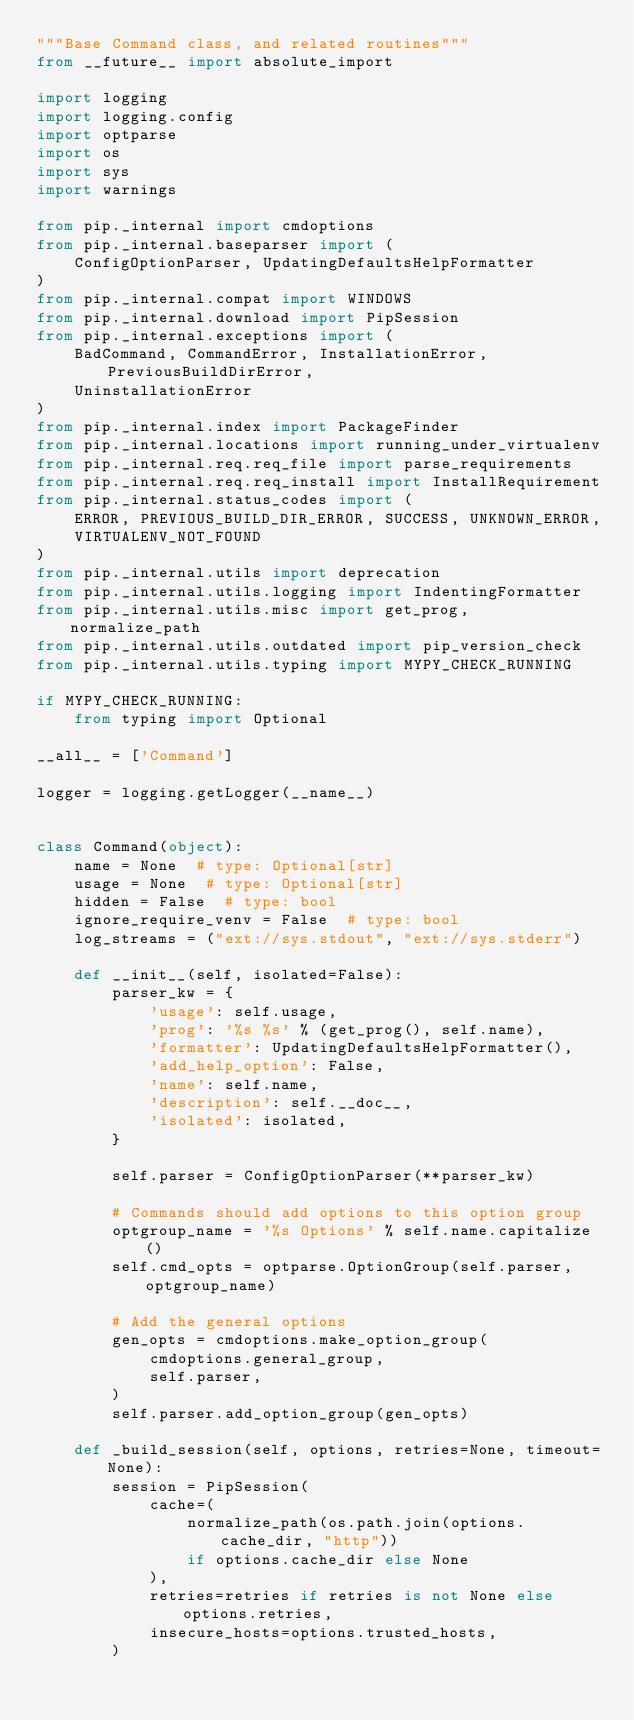<code> <loc_0><loc_0><loc_500><loc_500><_Python_>"""Base Command class, and related routines"""
from __future__ import absolute_import

import logging
import logging.config
import optparse
import os
import sys
import warnings

from pip._internal import cmdoptions
from pip._internal.baseparser import (
    ConfigOptionParser, UpdatingDefaultsHelpFormatter
)
from pip._internal.compat import WINDOWS
from pip._internal.download import PipSession
from pip._internal.exceptions import (
    BadCommand, CommandError, InstallationError, PreviousBuildDirError,
    UninstallationError
)
from pip._internal.index import PackageFinder
from pip._internal.locations import running_under_virtualenv
from pip._internal.req.req_file import parse_requirements
from pip._internal.req.req_install import InstallRequirement
from pip._internal.status_codes import (
    ERROR, PREVIOUS_BUILD_DIR_ERROR, SUCCESS, UNKNOWN_ERROR,
    VIRTUALENV_NOT_FOUND
)
from pip._internal.utils import deprecation
from pip._internal.utils.logging import IndentingFormatter
from pip._internal.utils.misc import get_prog, normalize_path
from pip._internal.utils.outdated import pip_version_check
from pip._internal.utils.typing import MYPY_CHECK_RUNNING

if MYPY_CHECK_RUNNING:
    from typing import Optional

__all__ = ['Command']

logger = logging.getLogger(__name__)


class Command(object):
    name = None  # type: Optional[str]
    usage = None  # type: Optional[str]
    hidden = False  # type: bool
    ignore_require_venv = False  # type: bool
    log_streams = ("ext://sys.stdout", "ext://sys.stderr")

    def __init__(self, isolated=False):
        parser_kw = {
            'usage': self.usage,
            'prog': '%s %s' % (get_prog(), self.name),
            'formatter': UpdatingDefaultsHelpFormatter(),
            'add_help_option': False,
            'name': self.name,
            'description': self.__doc__,
            'isolated': isolated,
        }

        self.parser = ConfigOptionParser(**parser_kw)

        # Commands should add options to this option group
        optgroup_name = '%s Options' % self.name.capitalize()
        self.cmd_opts = optparse.OptionGroup(self.parser, optgroup_name)

        # Add the general options
        gen_opts = cmdoptions.make_option_group(
            cmdoptions.general_group,
            self.parser,
        )
        self.parser.add_option_group(gen_opts)

    def _build_session(self, options, retries=None, timeout=None):
        session = PipSession(
            cache=(
                normalize_path(os.path.join(options.cache_dir, "http"))
                if options.cache_dir else None
            ),
            retries=retries if retries is not None else options.retries,
            insecure_hosts=options.trusted_hosts,
        )
</code> 